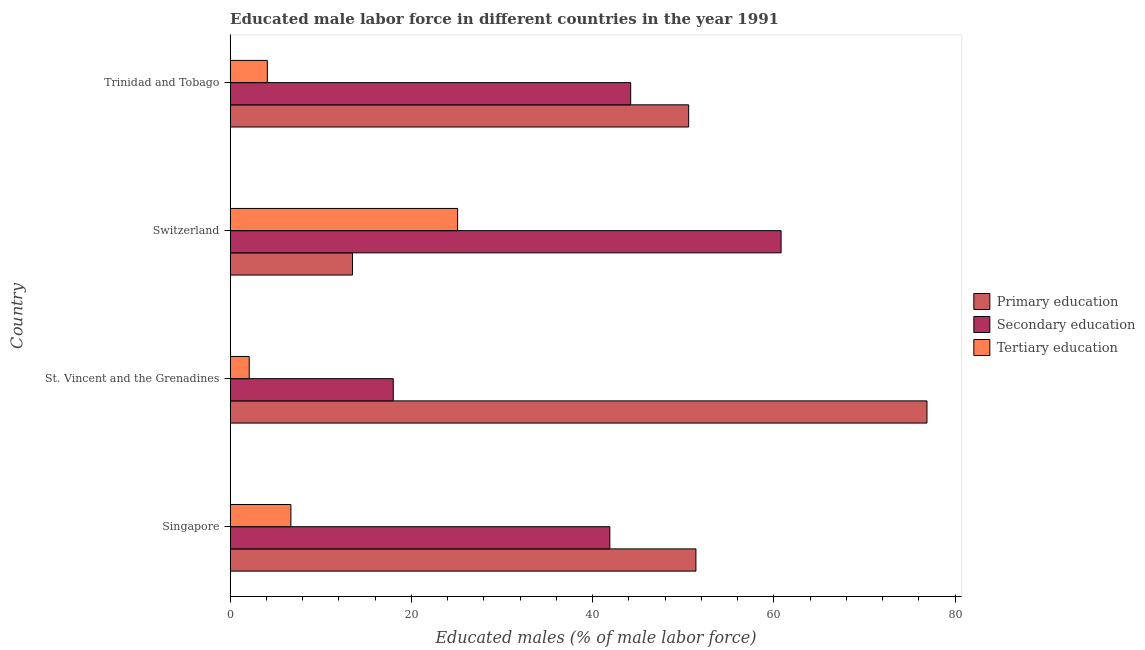How many different coloured bars are there?
Give a very brief answer. 3. Are the number of bars per tick equal to the number of legend labels?
Your response must be concise. Yes. Are the number of bars on each tick of the Y-axis equal?
Offer a very short reply. Yes. What is the label of the 1st group of bars from the top?
Offer a very short reply. Trinidad and Tobago. What is the percentage of male labor force who received primary education in Singapore?
Ensure brevity in your answer.  51.4. Across all countries, what is the maximum percentage of male labor force who received secondary education?
Your response must be concise. 60.8. Across all countries, what is the minimum percentage of male labor force who received tertiary education?
Provide a short and direct response. 2.1. In which country was the percentage of male labor force who received tertiary education maximum?
Provide a succinct answer. Switzerland. In which country was the percentage of male labor force who received primary education minimum?
Give a very brief answer. Switzerland. What is the total percentage of male labor force who received primary education in the graph?
Keep it short and to the point. 192.4. What is the difference between the percentage of male labor force who received secondary education in St. Vincent and the Grenadines and that in Trinidad and Tobago?
Ensure brevity in your answer.  -26.2. What is the difference between the percentage of male labor force who received secondary education in Trinidad and Tobago and the percentage of male labor force who received primary education in Singapore?
Offer a very short reply. -7.2. What is the average percentage of male labor force who received tertiary education per country?
Keep it short and to the point. 9.5. What is the ratio of the percentage of male labor force who received secondary education in Switzerland to that in Trinidad and Tobago?
Your answer should be very brief. 1.38. What is the difference between the highest and the lowest percentage of male labor force who received secondary education?
Keep it short and to the point. 42.8. In how many countries, is the percentage of male labor force who received primary education greater than the average percentage of male labor force who received primary education taken over all countries?
Provide a short and direct response. 3. What does the 1st bar from the top in Switzerland represents?
Your answer should be very brief. Tertiary education. What does the 1st bar from the bottom in Singapore represents?
Provide a succinct answer. Primary education. Is it the case that in every country, the sum of the percentage of male labor force who received primary education and percentage of male labor force who received secondary education is greater than the percentage of male labor force who received tertiary education?
Offer a terse response. Yes. Are all the bars in the graph horizontal?
Ensure brevity in your answer.  Yes. What is the difference between two consecutive major ticks on the X-axis?
Ensure brevity in your answer.  20. Are the values on the major ticks of X-axis written in scientific E-notation?
Provide a short and direct response. No. Does the graph contain any zero values?
Ensure brevity in your answer.  No. Does the graph contain grids?
Give a very brief answer. No. How are the legend labels stacked?
Your answer should be compact. Vertical. What is the title of the graph?
Your response must be concise. Educated male labor force in different countries in the year 1991. What is the label or title of the X-axis?
Provide a short and direct response. Educated males (% of male labor force). What is the Educated males (% of male labor force) of Primary education in Singapore?
Your answer should be very brief. 51.4. What is the Educated males (% of male labor force) of Secondary education in Singapore?
Your response must be concise. 41.9. What is the Educated males (% of male labor force) of Tertiary education in Singapore?
Give a very brief answer. 6.7. What is the Educated males (% of male labor force) of Primary education in St. Vincent and the Grenadines?
Your response must be concise. 76.9. What is the Educated males (% of male labor force) in Tertiary education in St. Vincent and the Grenadines?
Provide a succinct answer. 2.1. What is the Educated males (% of male labor force) of Secondary education in Switzerland?
Your answer should be compact. 60.8. What is the Educated males (% of male labor force) of Tertiary education in Switzerland?
Your answer should be very brief. 25.1. What is the Educated males (% of male labor force) in Primary education in Trinidad and Tobago?
Give a very brief answer. 50.6. What is the Educated males (% of male labor force) in Secondary education in Trinidad and Tobago?
Provide a short and direct response. 44.2. What is the Educated males (% of male labor force) in Tertiary education in Trinidad and Tobago?
Ensure brevity in your answer.  4.1. Across all countries, what is the maximum Educated males (% of male labor force) in Primary education?
Make the answer very short. 76.9. Across all countries, what is the maximum Educated males (% of male labor force) in Secondary education?
Give a very brief answer. 60.8. Across all countries, what is the maximum Educated males (% of male labor force) of Tertiary education?
Make the answer very short. 25.1. Across all countries, what is the minimum Educated males (% of male labor force) in Tertiary education?
Provide a succinct answer. 2.1. What is the total Educated males (% of male labor force) of Primary education in the graph?
Ensure brevity in your answer.  192.4. What is the total Educated males (% of male labor force) of Secondary education in the graph?
Your answer should be compact. 164.9. What is the total Educated males (% of male labor force) of Tertiary education in the graph?
Your answer should be compact. 38. What is the difference between the Educated males (% of male labor force) in Primary education in Singapore and that in St. Vincent and the Grenadines?
Ensure brevity in your answer.  -25.5. What is the difference between the Educated males (% of male labor force) in Secondary education in Singapore and that in St. Vincent and the Grenadines?
Give a very brief answer. 23.9. What is the difference between the Educated males (% of male labor force) in Tertiary education in Singapore and that in St. Vincent and the Grenadines?
Provide a succinct answer. 4.6. What is the difference between the Educated males (% of male labor force) of Primary education in Singapore and that in Switzerland?
Provide a short and direct response. 37.9. What is the difference between the Educated males (% of male labor force) of Secondary education in Singapore and that in Switzerland?
Make the answer very short. -18.9. What is the difference between the Educated males (% of male labor force) in Tertiary education in Singapore and that in Switzerland?
Provide a short and direct response. -18.4. What is the difference between the Educated males (% of male labor force) of Primary education in St. Vincent and the Grenadines and that in Switzerland?
Your answer should be compact. 63.4. What is the difference between the Educated males (% of male labor force) of Secondary education in St. Vincent and the Grenadines and that in Switzerland?
Your answer should be very brief. -42.8. What is the difference between the Educated males (% of male labor force) of Primary education in St. Vincent and the Grenadines and that in Trinidad and Tobago?
Offer a terse response. 26.3. What is the difference between the Educated males (% of male labor force) in Secondary education in St. Vincent and the Grenadines and that in Trinidad and Tobago?
Give a very brief answer. -26.2. What is the difference between the Educated males (% of male labor force) of Tertiary education in St. Vincent and the Grenadines and that in Trinidad and Tobago?
Make the answer very short. -2. What is the difference between the Educated males (% of male labor force) in Primary education in Switzerland and that in Trinidad and Tobago?
Ensure brevity in your answer.  -37.1. What is the difference between the Educated males (% of male labor force) in Tertiary education in Switzerland and that in Trinidad and Tobago?
Give a very brief answer. 21. What is the difference between the Educated males (% of male labor force) in Primary education in Singapore and the Educated males (% of male labor force) in Secondary education in St. Vincent and the Grenadines?
Provide a short and direct response. 33.4. What is the difference between the Educated males (% of male labor force) of Primary education in Singapore and the Educated males (% of male labor force) of Tertiary education in St. Vincent and the Grenadines?
Your answer should be very brief. 49.3. What is the difference between the Educated males (% of male labor force) of Secondary education in Singapore and the Educated males (% of male labor force) of Tertiary education in St. Vincent and the Grenadines?
Keep it short and to the point. 39.8. What is the difference between the Educated males (% of male labor force) of Primary education in Singapore and the Educated males (% of male labor force) of Secondary education in Switzerland?
Your answer should be very brief. -9.4. What is the difference between the Educated males (% of male labor force) in Primary education in Singapore and the Educated males (% of male labor force) in Tertiary education in Switzerland?
Provide a succinct answer. 26.3. What is the difference between the Educated males (% of male labor force) of Primary education in Singapore and the Educated males (% of male labor force) of Secondary education in Trinidad and Tobago?
Your answer should be compact. 7.2. What is the difference between the Educated males (% of male labor force) in Primary education in Singapore and the Educated males (% of male labor force) in Tertiary education in Trinidad and Tobago?
Provide a short and direct response. 47.3. What is the difference between the Educated males (% of male labor force) of Secondary education in Singapore and the Educated males (% of male labor force) of Tertiary education in Trinidad and Tobago?
Your answer should be compact. 37.8. What is the difference between the Educated males (% of male labor force) in Primary education in St. Vincent and the Grenadines and the Educated males (% of male labor force) in Secondary education in Switzerland?
Provide a succinct answer. 16.1. What is the difference between the Educated males (% of male labor force) in Primary education in St. Vincent and the Grenadines and the Educated males (% of male labor force) in Tertiary education in Switzerland?
Ensure brevity in your answer.  51.8. What is the difference between the Educated males (% of male labor force) of Secondary education in St. Vincent and the Grenadines and the Educated males (% of male labor force) of Tertiary education in Switzerland?
Provide a succinct answer. -7.1. What is the difference between the Educated males (% of male labor force) in Primary education in St. Vincent and the Grenadines and the Educated males (% of male labor force) in Secondary education in Trinidad and Tobago?
Ensure brevity in your answer.  32.7. What is the difference between the Educated males (% of male labor force) in Primary education in St. Vincent and the Grenadines and the Educated males (% of male labor force) in Tertiary education in Trinidad and Tobago?
Offer a very short reply. 72.8. What is the difference between the Educated males (% of male labor force) in Primary education in Switzerland and the Educated males (% of male labor force) in Secondary education in Trinidad and Tobago?
Keep it short and to the point. -30.7. What is the difference between the Educated males (% of male labor force) of Primary education in Switzerland and the Educated males (% of male labor force) of Tertiary education in Trinidad and Tobago?
Ensure brevity in your answer.  9.4. What is the difference between the Educated males (% of male labor force) in Secondary education in Switzerland and the Educated males (% of male labor force) in Tertiary education in Trinidad and Tobago?
Make the answer very short. 56.7. What is the average Educated males (% of male labor force) of Primary education per country?
Offer a very short reply. 48.1. What is the average Educated males (% of male labor force) of Secondary education per country?
Offer a very short reply. 41.23. What is the difference between the Educated males (% of male labor force) of Primary education and Educated males (% of male labor force) of Secondary education in Singapore?
Your response must be concise. 9.5. What is the difference between the Educated males (% of male labor force) of Primary education and Educated males (% of male labor force) of Tertiary education in Singapore?
Offer a very short reply. 44.7. What is the difference between the Educated males (% of male labor force) in Secondary education and Educated males (% of male labor force) in Tertiary education in Singapore?
Ensure brevity in your answer.  35.2. What is the difference between the Educated males (% of male labor force) in Primary education and Educated males (% of male labor force) in Secondary education in St. Vincent and the Grenadines?
Ensure brevity in your answer.  58.9. What is the difference between the Educated males (% of male labor force) of Primary education and Educated males (% of male labor force) of Tertiary education in St. Vincent and the Grenadines?
Provide a succinct answer. 74.8. What is the difference between the Educated males (% of male labor force) of Primary education and Educated males (% of male labor force) of Secondary education in Switzerland?
Give a very brief answer. -47.3. What is the difference between the Educated males (% of male labor force) of Secondary education and Educated males (% of male labor force) of Tertiary education in Switzerland?
Offer a very short reply. 35.7. What is the difference between the Educated males (% of male labor force) in Primary education and Educated males (% of male labor force) in Secondary education in Trinidad and Tobago?
Give a very brief answer. 6.4. What is the difference between the Educated males (% of male labor force) in Primary education and Educated males (% of male labor force) in Tertiary education in Trinidad and Tobago?
Ensure brevity in your answer.  46.5. What is the difference between the Educated males (% of male labor force) of Secondary education and Educated males (% of male labor force) of Tertiary education in Trinidad and Tobago?
Keep it short and to the point. 40.1. What is the ratio of the Educated males (% of male labor force) of Primary education in Singapore to that in St. Vincent and the Grenadines?
Your answer should be compact. 0.67. What is the ratio of the Educated males (% of male labor force) in Secondary education in Singapore to that in St. Vincent and the Grenadines?
Make the answer very short. 2.33. What is the ratio of the Educated males (% of male labor force) of Tertiary education in Singapore to that in St. Vincent and the Grenadines?
Provide a short and direct response. 3.19. What is the ratio of the Educated males (% of male labor force) of Primary education in Singapore to that in Switzerland?
Provide a short and direct response. 3.81. What is the ratio of the Educated males (% of male labor force) of Secondary education in Singapore to that in Switzerland?
Your answer should be compact. 0.69. What is the ratio of the Educated males (% of male labor force) in Tertiary education in Singapore to that in Switzerland?
Make the answer very short. 0.27. What is the ratio of the Educated males (% of male labor force) of Primary education in Singapore to that in Trinidad and Tobago?
Give a very brief answer. 1.02. What is the ratio of the Educated males (% of male labor force) in Secondary education in Singapore to that in Trinidad and Tobago?
Your response must be concise. 0.95. What is the ratio of the Educated males (% of male labor force) of Tertiary education in Singapore to that in Trinidad and Tobago?
Make the answer very short. 1.63. What is the ratio of the Educated males (% of male labor force) of Primary education in St. Vincent and the Grenadines to that in Switzerland?
Your response must be concise. 5.7. What is the ratio of the Educated males (% of male labor force) of Secondary education in St. Vincent and the Grenadines to that in Switzerland?
Your response must be concise. 0.3. What is the ratio of the Educated males (% of male labor force) of Tertiary education in St. Vincent and the Grenadines to that in Switzerland?
Offer a very short reply. 0.08. What is the ratio of the Educated males (% of male labor force) in Primary education in St. Vincent and the Grenadines to that in Trinidad and Tobago?
Give a very brief answer. 1.52. What is the ratio of the Educated males (% of male labor force) of Secondary education in St. Vincent and the Grenadines to that in Trinidad and Tobago?
Ensure brevity in your answer.  0.41. What is the ratio of the Educated males (% of male labor force) in Tertiary education in St. Vincent and the Grenadines to that in Trinidad and Tobago?
Offer a very short reply. 0.51. What is the ratio of the Educated males (% of male labor force) in Primary education in Switzerland to that in Trinidad and Tobago?
Offer a terse response. 0.27. What is the ratio of the Educated males (% of male labor force) of Secondary education in Switzerland to that in Trinidad and Tobago?
Provide a short and direct response. 1.38. What is the ratio of the Educated males (% of male labor force) in Tertiary education in Switzerland to that in Trinidad and Tobago?
Your response must be concise. 6.12. What is the difference between the highest and the second highest Educated males (% of male labor force) in Secondary education?
Your answer should be very brief. 16.6. What is the difference between the highest and the second highest Educated males (% of male labor force) in Tertiary education?
Your answer should be compact. 18.4. What is the difference between the highest and the lowest Educated males (% of male labor force) in Primary education?
Ensure brevity in your answer.  63.4. What is the difference between the highest and the lowest Educated males (% of male labor force) in Secondary education?
Your answer should be compact. 42.8. What is the difference between the highest and the lowest Educated males (% of male labor force) of Tertiary education?
Provide a short and direct response. 23. 